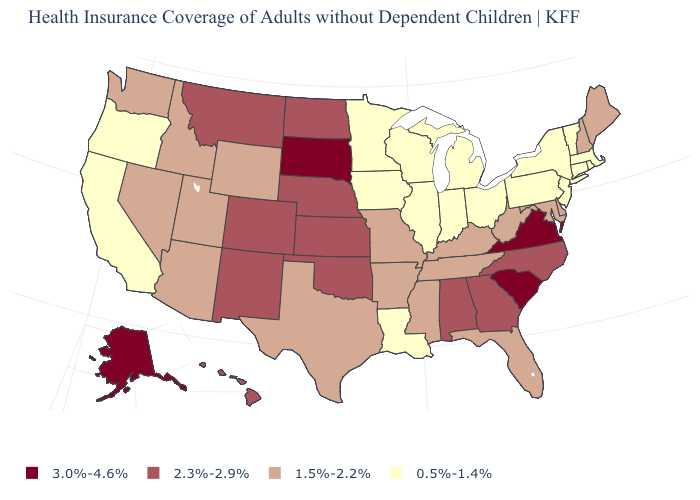Does South Carolina have the highest value in the USA?
Concise answer only. Yes. Name the states that have a value in the range 0.5%-1.4%?
Be succinct. California, Connecticut, Illinois, Indiana, Iowa, Louisiana, Massachusetts, Michigan, Minnesota, New Jersey, New York, Ohio, Oregon, Pennsylvania, Rhode Island, Vermont, Wisconsin. What is the value of Oklahoma?
Give a very brief answer. 2.3%-2.9%. What is the value of North Dakota?
Give a very brief answer. 2.3%-2.9%. Does Idaho have the lowest value in the West?
Be succinct. No. Among the states that border Mississippi , does Tennessee have the lowest value?
Quick response, please. No. Does Alaska have the highest value in the West?
Be succinct. Yes. Among the states that border Delaware , does Maryland have the lowest value?
Concise answer only. No. Does South Dakota have the highest value in the MidWest?
Keep it brief. Yes. Does the first symbol in the legend represent the smallest category?
Give a very brief answer. No. What is the highest value in the USA?
Write a very short answer. 3.0%-4.6%. Name the states that have a value in the range 3.0%-4.6%?
Short answer required. Alaska, South Carolina, South Dakota, Virginia. Which states have the lowest value in the USA?
Answer briefly. California, Connecticut, Illinois, Indiana, Iowa, Louisiana, Massachusetts, Michigan, Minnesota, New Jersey, New York, Ohio, Oregon, Pennsylvania, Rhode Island, Vermont, Wisconsin. What is the highest value in the MidWest ?
Answer briefly. 3.0%-4.6%. What is the value of Connecticut?
Give a very brief answer. 0.5%-1.4%. 